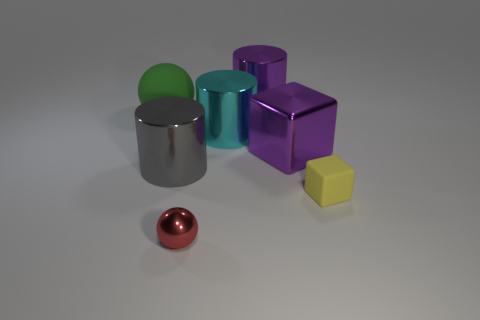Is the number of large gray metal cylinders that are in front of the tiny red ball the same as the number of small rubber objects that are in front of the big rubber object?
Your answer should be very brief. No. What number of cubes are green objects or tiny red things?
Give a very brief answer. 0. What number of other objects are there of the same material as the purple cylinder?
Provide a short and direct response. 4. The matte object left of the small rubber thing has what shape?
Keep it short and to the point. Sphere. What material is the big purple thing in front of the purple metal object behind the cyan thing?
Keep it short and to the point. Metal. Are there more metallic balls behind the cyan shiny object than tiny gray metallic spheres?
Your response must be concise. No. What number of other objects are there of the same color as the tiny shiny sphere?
Provide a succinct answer. 0. There is another rubber object that is the same size as the red thing; what is its shape?
Give a very brief answer. Cube. What number of red metallic spheres are behind the thing in front of the matte thing that is to the right of the large cube?
Keep it short and to the point. 0. What number of rubber things are small red spheres or big purple cylinders?
Provide a succinct answer. 0. 